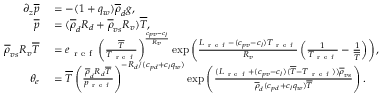<formula> <loc_0><loc_0><loc_500><loc_500>\begin{array} { r l } { \partial _ { z } \overline { p } } & = - ( 1 + q _ { w } ) \overline { \rho } _ { d } g , } \\ { \overline { p } } & = ( \overline { \rho } _ { d } R _ { d } + \overline { \rho } _ { v s } R _ { v } ) \overline { T } , } \\ { \overline { \rho } _ { v s } R _ { v } \overline { T } } & = e _ { r e f } \left ( \frac { \overline { T } } { T _ { r e f } } \right ) ^ { \frac { c _ { p v } - c _ { l } } { R _ { v } } } \exp \left ( \frac { L _ { r e f } - ( c _ { p v } - c _ { l } ) T _ { r e f } } { R _ { v } } \left ( \frac { 1 } { T _ { r e f } } - \frac { 1 } { \overline { T } } \right ) \right ) , } \\ { \theta _ { e } } & = \overline { T } \left ( \frac { \overline { \rho } _ { d } R _ { d } \overline { T } } { p _ { r e f } } \right ) ^ { - R _ { d } / ( c _ { p d } + c _ { l } q _ { w } ) } \exp \left ( \frac { ( L _ { r e f } + ( c _ { p v } - c _ { l } ) ( \overline { T } - T _ { r e f } ) ) \overline { \rho } _ { v s } } { \overline { \rho } _ { d } ( c _ { p d } + c _ { l } q _ { w } ) \overline { T } } \right ) . } \end{array}</formula> 